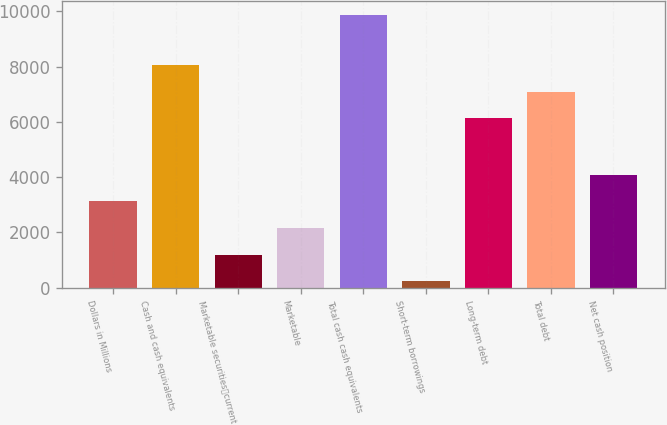<chart> <loc_0><loc_0><loc_500><loc_500><bar_chart><fcel>Dollars in Millions<fcel>Cash and cash equivalents<fcel>Marketable securitiescurrent<fcel>Marketable<fcel>Total cash cash equivalents<fcel>Short-term borrowings<fcel>Long-term debt<fcel>Total debt<fcel>Net cash position<nl><fcel>3126.6<fcel>8060.4<fcel>1196.2<fcel>2161.4<fcel>9883<fcel>231<fcel>6130<fcel>7095.2<fcel>4091.8<nl></chart> 